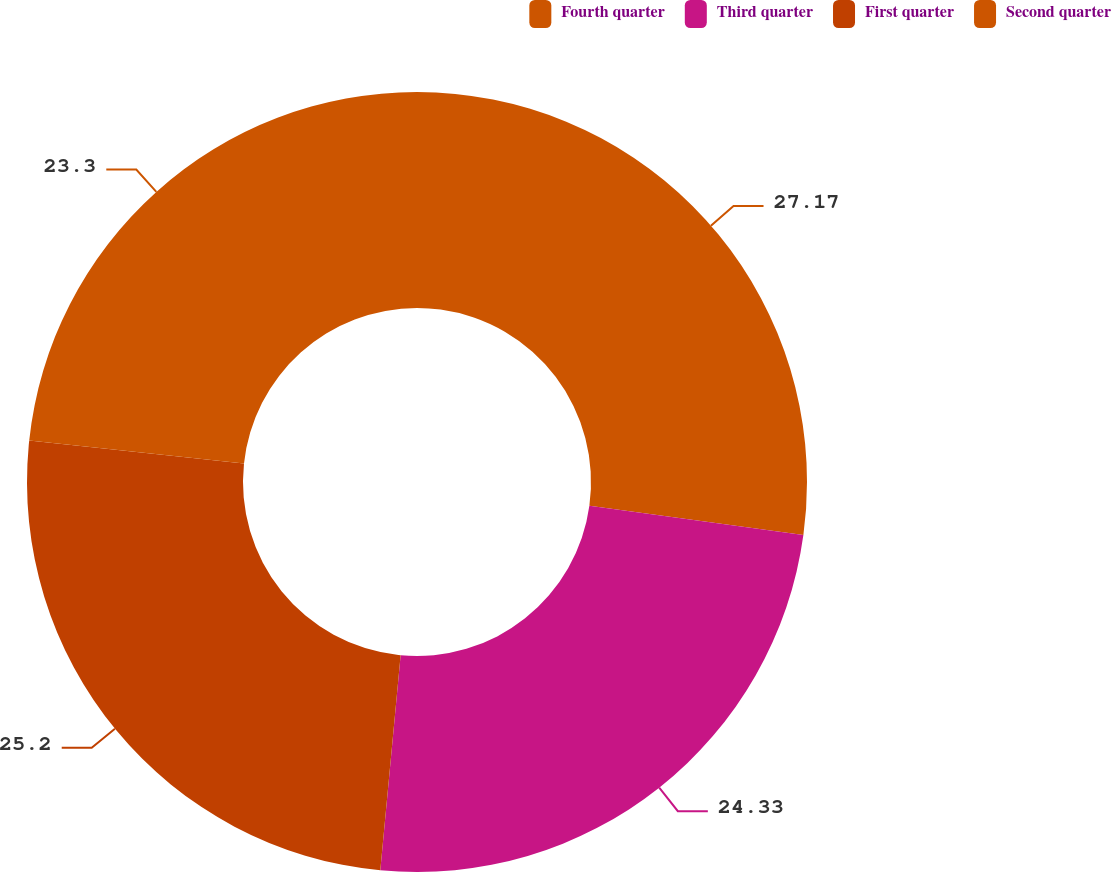Convert chart to OTSL. <chart><loc_0><loc_0><loc_500><loc_500><pie_chart><fcel>Fourth quarter<fcel>Third quarter<fcel>First quarter<fcel>Second quarter<nl><fcel>27.17%<fcel>24.33%<fcel>25.2%<fcel>23.3%<nl></chart> 